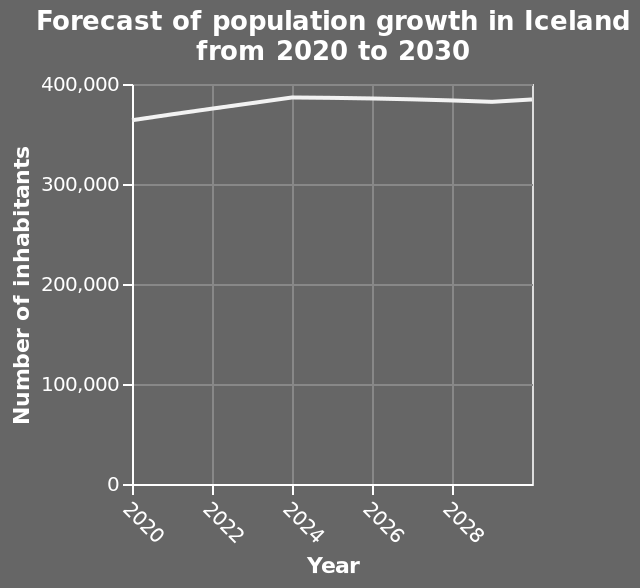<image>
What is the time frame represented on the line chart? The line chart represents the population growth forecast in Iceland from 2020 to 2030. What is the forecasted population growth trend? The forecasted population growth trend is expected to remain consistently just below 400,000. What is the expected population range according to the graph? According to the graph, the expected population range is consistently just below 400,000. What is the range of the y-axis?  The range of the y-axis is from 0 to 400,000, labeled as "Number of inhabitants." What is the title of the line chart?  The title of the line chart is "Forecast of population growth in Iceland from 2020 to 2030." please describe the details of the chart Here a is a line chart labeled Forecast of population growth in Iceland from 2020 to 2030. There is a linear scale of range 0 to 400,000 on the y-axis, labeled Number of inhabitants. There is a linear scale with a minimum of 2020 and a maximum of 2028 along the x-axis, labeled Year. 